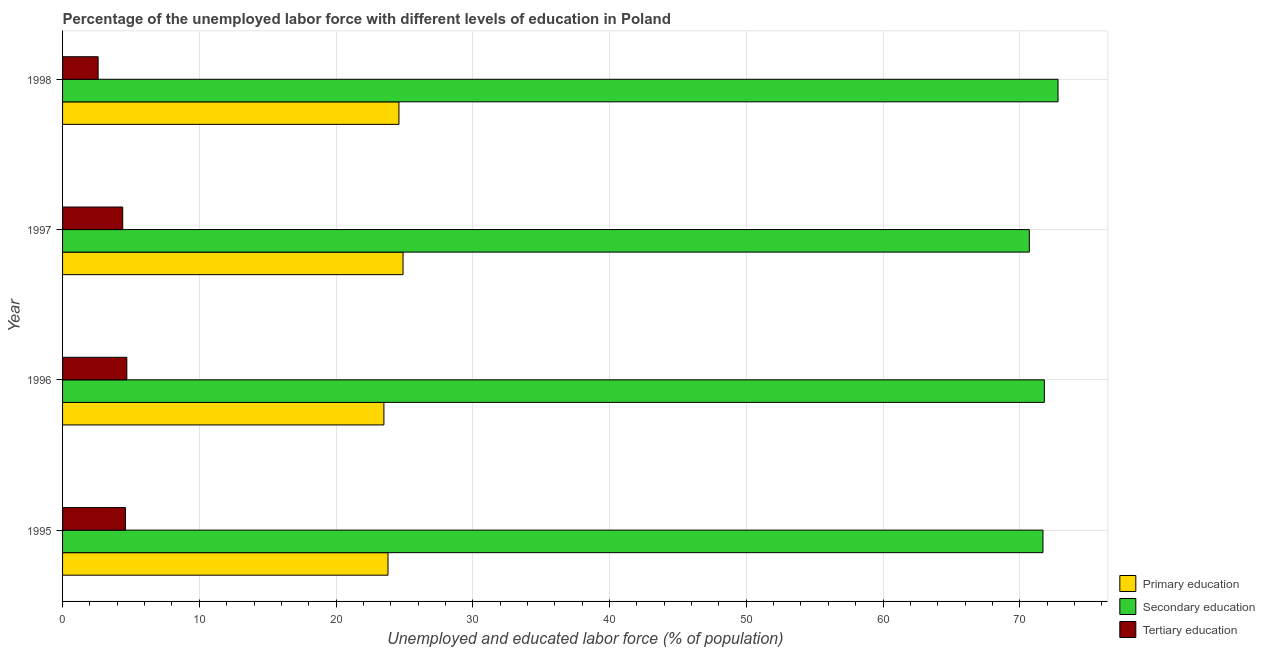How many different coloured bars are there?
Make the answer very short. 3. How many groups of bars are there?
Provide a short and direct response. 4. What is the percentage of labor force who received tertiary education in 1995?
Provide a succinct answer. 4.6. Across all years, what is the maximum percentage of labor force who received primary education?
Your answer should be compact. 24.9. Across all years, what is the minimum percentage of labor force who received tertiary education?
Offer a very short reply. 2.6. In which year was the percentage of labor force who received tertiary education maximum?
Ensure brevity in your answer.  1996. In which year was the percentage of labor force who received tertiary education minimum?
Offer a very short reply. 1998. What is the total percentage of labor force who received tertiary education in the graph?
Your answer should be compact. 16.3. What is the difference between the percentage of labor force who received tertiary education in 1996 and that in 1998?
Your answer should be compact. 2.1. What is the difference between the percentage of labor force who received primary education in 1997 and the percentage of labor force who received tertiary education in 1998?
Give a very brief answer. 22.3. What is the average percentage of labor force who received secondary education per year?
Your answer should be compact. 71.75. In the year 1996, what is the difference between the percentage of labor force who received secondary education and percentage of labor force who received primary education?
Provide a short and direct response. 48.3. What is the ratio of the percentage of labor force who received primary education in 1995 to that in 1998?
Give a very brief answer. 0.97. In how many years, is the percentage of labor force who received primary education greater than the average percentage of labor force who received primary education taken over all years?
Provide a short and direct response. 2. What does the 3rd bar from the top in 1995 represents?
Keep it short and to the point. Primary education. What does the 2nd bar from the bottom in 1995 represents?
Ensure brevity in your answer.  Secondary education. Is it the case that in every year, the sum of the percentage of labor force who received primary education and percentage of labor force who received secondary education is greater than the percentage of labor force who received tertiary education?
Provide a short and direct response. Yes. How many bars are there?
Provide a succinct answer. 12. Are all the bars in the graph horizontal?
Offer a terse response. Yes. How many years are there in the graph?
Ensure brevity in your answer.  4. What is the difference between two consecutive major ticks on the X-axis?
Offer a very short reply. 10. Does the graph contain any zero values?
Your answer should be very brief. No. Does the graph contain grids?
Your answer should be compact. Yes. How are the legend labels stacked?
Provide a short and direct response. Vertical. What is the title of the graph?
Give a very brief answer. Percentage of the unemployed labor force with different levels of education in Poland. Does "Textiles and clothing" appear as one of the legend labels in the graph?
Your answer should be compact. No. What is the label or title of the X-axis?
Offer a terse response. Unemployed and educated labor force (% of population). What is the label or title of the Y-axis?
Offer a very short reply. Year. What is the Unemployed and educated labor force (% of population) of Primary education in 1995?
Provide a succinct answer. 23.8. What is the Unemployed and educated labor force (% of population) in Secondary education in 1995?
Your answer should be very brief. 71.7. What is the Unemployed and educated labor force (% of population) of Tertiary education in 1995?
Offer a terse response. 4.6. What is the Unemployed and educated labor force (% of population) of Primary education in 1996?
Give a very brief answer. 23.5. What is the Unemployed and educated labor force (% of population) in Secondary education in 1996?
Offer a very short reply. 71.8. What is the Unemployed and educated labor force (% of population) in Tertiary education in 1996?
Offer a terse response. 4.7. What is the Unemployed and educated labor force (% of population) in Primary education in 1997?
Offer a very short reply. 24.9. What is the Unemployed and educated labor force (% of population) of Secondary education in 1997?
Your answer should be very brief. 70.7. What is the Unemployed and educated labor force (% of population) of Tertiary education in 1997?
Offer a terse response. 4.4. What is the Unemployed and educated labor force (% of population) of Primary education in 1998?
Your answer should be compact. 24.6. What is the Unemployed and educated labor force (% of population) of Secondary education in 1998?
Make the answer very short. 72.8. What is the Unemployed and educated labor force (% of population) in Tertiary education in 1998?
Keep it short and to the point. 2.6. Across all years, what is the maximum Unemployed and educated labor force (% of population) in Primary education?
Your answer should be very brief. 24.9. Across all years, what is the maximum Unemployed and educated labor force (% of population) of Secondary education?
Offer a terse response. 72.8. Across all years, what is the maximum Unemployed and educated labor force (% of population) in Tertiary education?
Offer a terse response. 4.7. Across all years, what is the minimum Unemployed and educated labor force (% of population) of Secondary education?
Your response must be concise. 70.7. Across all years, what is the minimum Unemployed and educated labor force (% of population) in Tertiary education?
Your answer should be very brief. 2.6. What is the total Unemployed and educated labor force (% of population) of Primary education in the graph?
Provide a short and direct response. 96.8. What is the total Unemployed and educated labor force (% of population) of Secondary education in the graph?
Give a very brief answer. 287. What is the difference between the Unemployed and educated labor force (% of population) in Secondary education in 1995 and that in 1996?
Offer a very short reply. -0.1. What is the difference between the Unemployed and educated labor force (% of population) of Secondary education in 1995 and that in 1997?
Offer a very short reply. 1. What is the difference between the Unemployed and educated labor force (% of population) in Primary education in 1995 and that in 1998?
Your answer should be very brief. -0.8. What is the difference between the Unemployed and educated labor force (% of population) of Secondary education in 1995 and that in 1998?
Ensure brevity in your answer.  -1.1. What is the difference between the Unemployed and educated labor force (% of population) in Primary education in 1996 and that in 1997?
Your answer should be very brief. -1.4. What is the difference between the Unemployed and educated labor force (% of population) of Primary education in 1997 and that in 1998?
Your response must be concise. 0.3. What is the difference between the Unemployed and educated labor force (% of population) in Secondary education in 1997 and that in 1998?
Ensure brevity in your answer.  -2.1. What is the difference between the Unemployed and educated labor force (% of population) of Tertiary education in 1997 and that in 1998?
Keep it short and to the point. 1.8. What is the difference between the Unemployed and educated labor force (% of population) in Primary education in 1995 and the Unemployed and educated labor force (% of population) in Secondary education in 1996?
Make the answer very short. -48. What is the difference between the Unemployed and educated labor force (% of population) in Primary education in 1995 and the Unemployed and educated labor force (% of population) in Secondary education in 1997?
Provide a succinct answer. -46.9. What is the difference between the Unemployed and educated labor force (% of population) in Secondary education in 1995 and the Unemployed and educated labor force (% of population) in Tertiary education in 1997?
Offer a very short reply. 67.3. What is the difference between the Unemployed and educated labor force (% of population) of Primary education in 1995 and the Unemployed and educated labor force (% of population) of Secondary education in 1998?
Offer a very short reply. -49. What is the difference between the Unemployed and educated labor force (% of population) in Primary education in 1995 and the Unemployed and educated labor force (% of population) in Tertiary education in 1998?
Make the answer very short. 21.2. What is the difference between the Unemployed and educated labor force (% of population) of Secondary education in 1995 and the Unemployed and educated labor force (% of population) of Tertiary education in 1998?
Make the answer very short. 69.1. What is the difference between the Unemployed and educated labor force (% of population) in Primary education in 1996 and the Unemployed and educated labor force (% of population) in Secondary education in 1997?
Give a very brief answer. -47.2. What is the difference between the Unemployed and educated labor force (% of population) of Secondary education in 1996 and the Unemployed and educated labor force (% of population) of Tertiary education in 1997?
Your response must be concise. 67.4. What is the difference between the Unemployed and educated labor force (% of population) in Primary education in 1996 and the Unemployed and educated labor force (% of population) in Secondary education in 1998?
Make the answer very short. -49.3. What is the difference between the Unemployed and educated labor force (% of population) in Primary education in 1996 and the Unemployed and educated labor force (% of population) in Tertiary education in 1998?
Offer a very short reply. 20.9. What is the difference between the Unemployed and educated labor force (% of population) in Secondary education in 1996 and the Unemployed and educated labor force (% of population) in Tertiary education in 1998?
Your answer should be very brief. 69.2. What is the difference between the Unemployed and educated labor force (% of population) of Primary education in 1997 and the Unemployed and educated labor force (% of population) of Secondary education in 1998?
Ensure brevity in your answer.  -47.9. What is the difference between the Unemployed and educated labor force (% of population) in Primary education in 1997 and the Unemployed and educated labor force (% of population) in Tertiary education in 1998?
Offer a terse response. 22.3. What is the difference between the Unemployed and educated labor force (% of population) of Secondary education in 1997 and the Unemployed and educated labor force (% of population) of Tertiary education in 1998?
Make the answer very short. 68.1. What is the average Unemployed and educated labor force (% of population) in Primary education per year?
Provide a short and direct response. 24.2. What is the average Unemployed and educated labor force (% of population) of Secondary education per year?
Your answer should be compact. 71.75. What is the average Unemployed and educated labor force (% of population) of Tertiary education per year?
Your answer should be compact. 4.08. In the year 1995, what is the difference between the Unemployed and educated labor force (% of population) of Primary education and Unemployed and educated labor force (% of population) of Secondary education?
Give a very brief answer. -47.9. In the year 1995, what is the difference between the Unemployed and educated labor force (% of population) of Primary education and Unemployed and educated labor force (% of population) of Tertiary education?
Ensure brevity in your answer.  19.2. In the year 1995, what is the difference between the Unemployed and educated labor force (% of population) of Secondary education and Unemployed and educated labor force (% of population) of Tertiary education?
Give a very brief answer. 67.1. In the year 1996, what is the difference between the Unemployed and educated labor force (% of population) of Primary education and Unemployed and educated labor force (% of population) of Secondary education?
Offer a terse response. -48.3. In the year 1996, what is the difference between the Unemployed and educated labor force (% of population) in Primary education and Unemployed and educated labor force (% of population) in Tertiary education?
Keep it short and to the point. 18.8. In the year 1996, what is the difference between the Unemployed and educated labor force (% of population) in Secondary education and Unemployed and educated labor force (% of population) in Tertiary education?
Offer a terse response. 67.1. In the year 1997, what is the difference between the Unemployed and educated labor force (% of population) in Primary education and Unemployed and educated labor force (% of population) in Secondary education?
Provide a short and direct response. -45.8. In the year 1997, what is the difference between the Unemployed and educated labor force (% of population) in Primary education and Unemployed and educated labor force (% of population) in Tertiary education?
Offer a very short reply. 20.5. In the year 1997, what is the difference between the Unemployed and educated labor force (% of population) in Secondary education and Unemployed and educated labor force (% of population) in Tertiary education?
Provide a short and direct response. 66.3. In the year 1998, what is the difference between the Unemployed and educated labor force (% of population) in Primary education and Unemployed and educated labor force (% of population) in Secondary education?
Your response must be concise. -48.2. In the year 1998, what is the difference between the Unemployed and educated labor force (% of population) in Primary education and Unemployed and educated labor force (% of population) in Tertiary education?
Keep it short and to the point. 22. In the year 1998, what is the difference between the Unemployed and educated labor force (% of population) of Secondary education and Unemployed and educated labor force (% of population) of Tertiary education?
Your answer should be compact. 70.2. What is the ratio of the Unemployed and educated labor force (% of population) in Primary education in 1995 to that in 1996?
Give a very brief answer. 1.01. What is the ratio of the Unemployed and educated labor force (% of population) of Secondary education in 1995 to that in 1996?
Offer a very short reply. 1. What is the ratio of the Unemployed and educated labor force (% of population) of Tertiary education in 1995 to that in 1996?
Provide a short and direct response. 0.98. What is the ratio of the Unemployed and educated labor force (% of population) of Primary education in 1995 to that in 1997?
Your answer should be very brief. 0.96. What is the ratio of the Unemployed and educated labor force (% of population) of Secondary education in 1995 to that in 1997?
Your answer should be very brief. 1.01. What is the ratio of the Unemployed and educated labor force (% of population) in Tertiary education in 1995 to that in 1997?
Make the answer very short. 1.05. What is the ratio of the Unemployed and educated labor force (% of population) of Primary education in 1995 to that in 1998?
Offer a terse response. 0.97. What is the ratio of the Unemployed and educated labor force (% of population) in Secondary education in 1995 to that in 1998?
Provide a succinct answer. 0.98. What is the ratio of the Unemployed and educated labor force (% of population) of Tertiary education in 1995 to that in 1998?
Offer a very short reply. 1.77. What is the ratio of the Unemployed and educated labor force (% of population) in Primary education in 1996 to that in 1997?
Keep it short and to the point. 0.94. What is the ratio of the Unemployed and educated labor force (% of population) in Secondary education in 1996 to that in 1997?
Ensure brevity in your answer.  1.02. What is the ratio of the Unemployed and educated labor force (% of population) of Tertiary education in 1996 to that in 1997?
Make the answer very short. 1.07. What is the ratio of the Unemployed and educated labor force (% of population) in Primary education in 1996 to that in 1998?
Offer a terse response. 0.96. What is the ratio of the Unemployed and educated labor force (% of population) in Secondary education in 1996 to that in 1998?
Offer a very short reply. 0.99. What is the ratio of the Unemployed and educated labor force (% of population) in Tertiary education in 1996 to that in 1998?
Provide a succinct answer. 1.81. What is the ratio of the Unemployed and educated labor force (% of population) of Primary education in 1997 to that in 1998?
Offer a terse response. 1.01. What is the ratio of the Unemployed and educated labor force (% of population) in Secondary education in 1997 to that in 1998?
Offer a very short reply. 0.97. What is the ratio of the Unemployed and educated labor force (% of population) of Tertiary education in 1997 to that in 1998?
Provide a succinct answer. 1.69. What is the difference between the highest and the second highest Unemployed and educated labor force (% of population) in Primary education?
Give a very brief answer. 0.3. What is the difference between the highest and the lowest Unemployed and educated labor force (% of population) in Primary education?
Offer a terse response. 1.4. What is the difference between the highest and the lowest Unemployed and educated labor force (% of population) of Secondary education?
Your response must be concise. 2.1. What is the difference between the highest and the lowest Unemployed and educated labor force (% of population) of Tertiary education?
Ensure brevity in your answer.  2.1. 